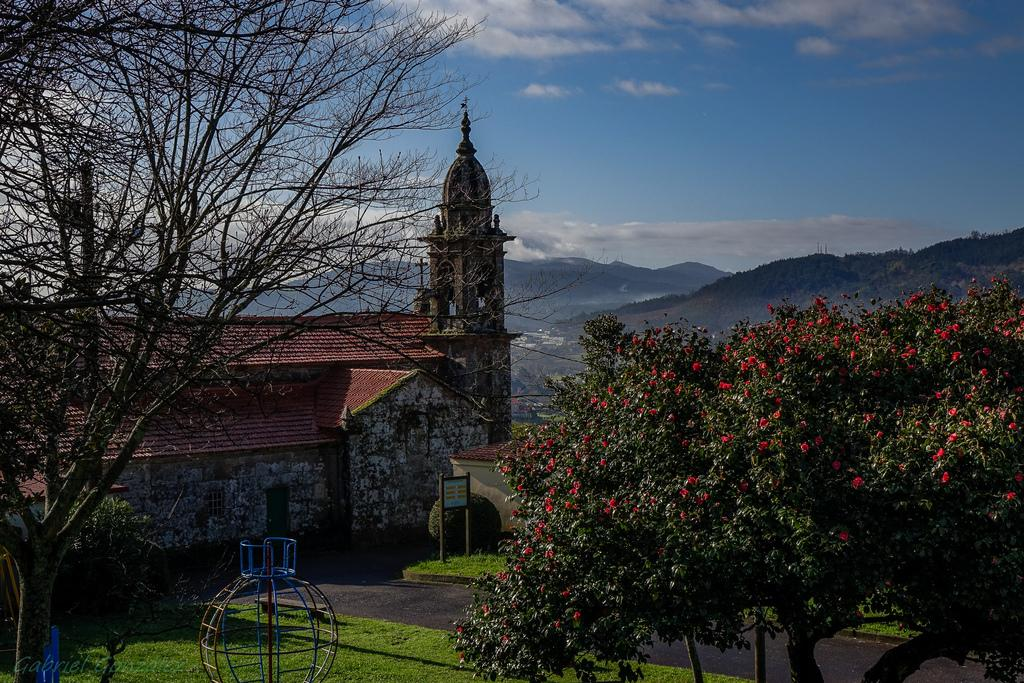What type of vegetation is present in the image? There are trees and grass in the image. What type of structure can be seen in the image? There is a house in the image. What type of terrain is visible in the image? There are hills in the image. What is the color of the sky in the background? The sky is blue in the background. What else can be seen in the sky? There are clouds in the sky. What type of scissors are being used to cut the grass in the image? There are no scissors present in the image; the grass is not being cut. What color is the pin used to hold the clouds in the sky? There is no pin present in the image; the clouds are not being held in place. 